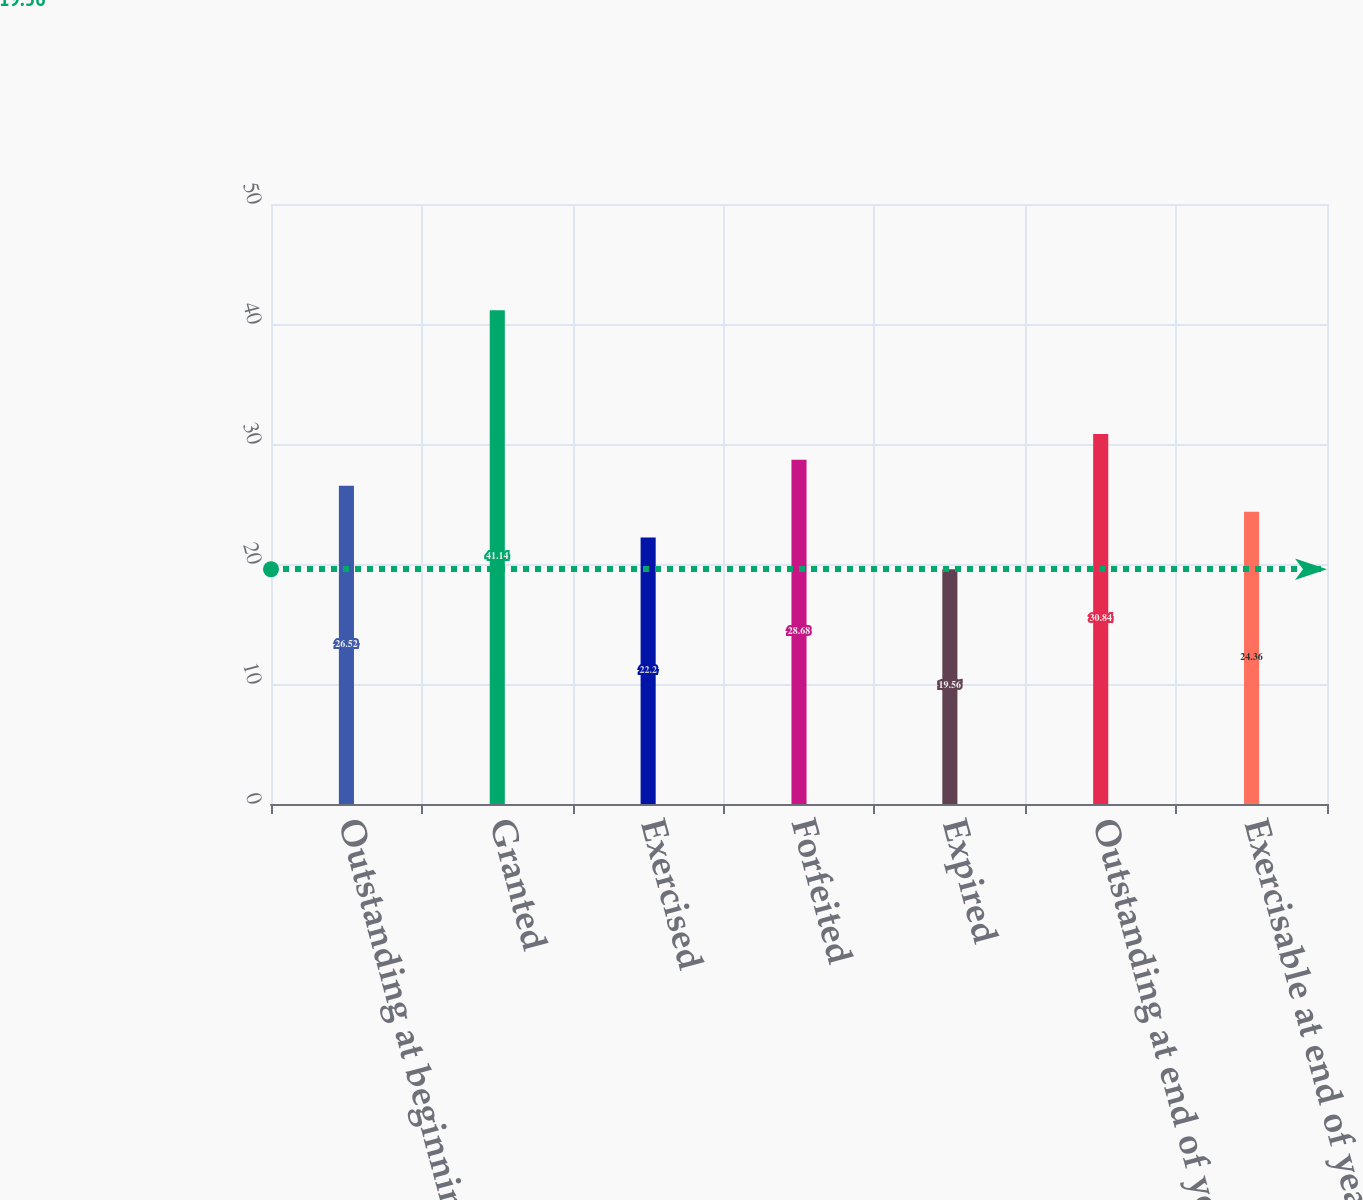Convert chart to OTSL. <chart><loc_0><loc_0><loc_500><loc_500><bar_chart><fcel>Outstanding at beginning of<fcel>Granted<fcel>Exercised<fcel>Forfeited<fcel>Expired<fcel>Outstanding at end of year<fcel>Exercisable at end of year<nl><fcel>26.52<fcel>41.14<fcel>22.2<fcel>28.68<fcel>19.56<fcel>30.84<fcel>24.36<nl></chart> 